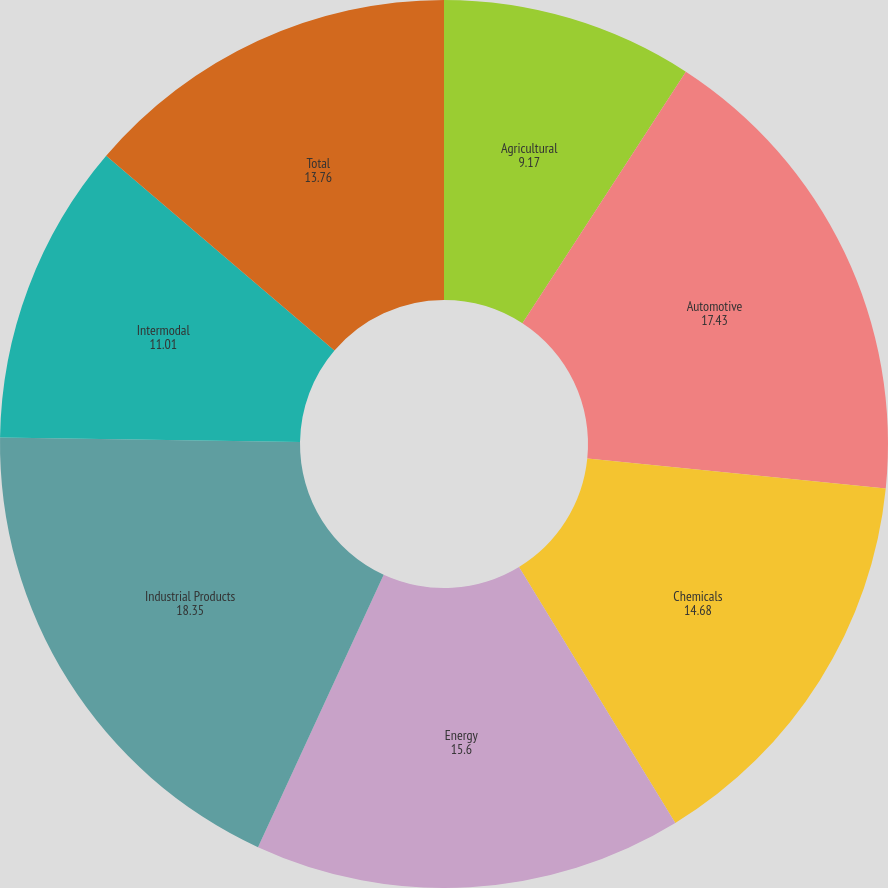Convert chart. <chart><loc_0><loc_0><loc_500><loc_500><pie_chart><fcel>Agricultural<fcel>Automotive<fcel>Chemicals<fcel>Energy<fcel>Industrial Products<fcel>Intermodal<fcel>Total<nl><fcel>9.17%<fcel>17.43%<fcel>14.68%<fcel>15.6%<fcel>18.35%<fcel>11.01%<fcel>13.76%<nl></chart> 